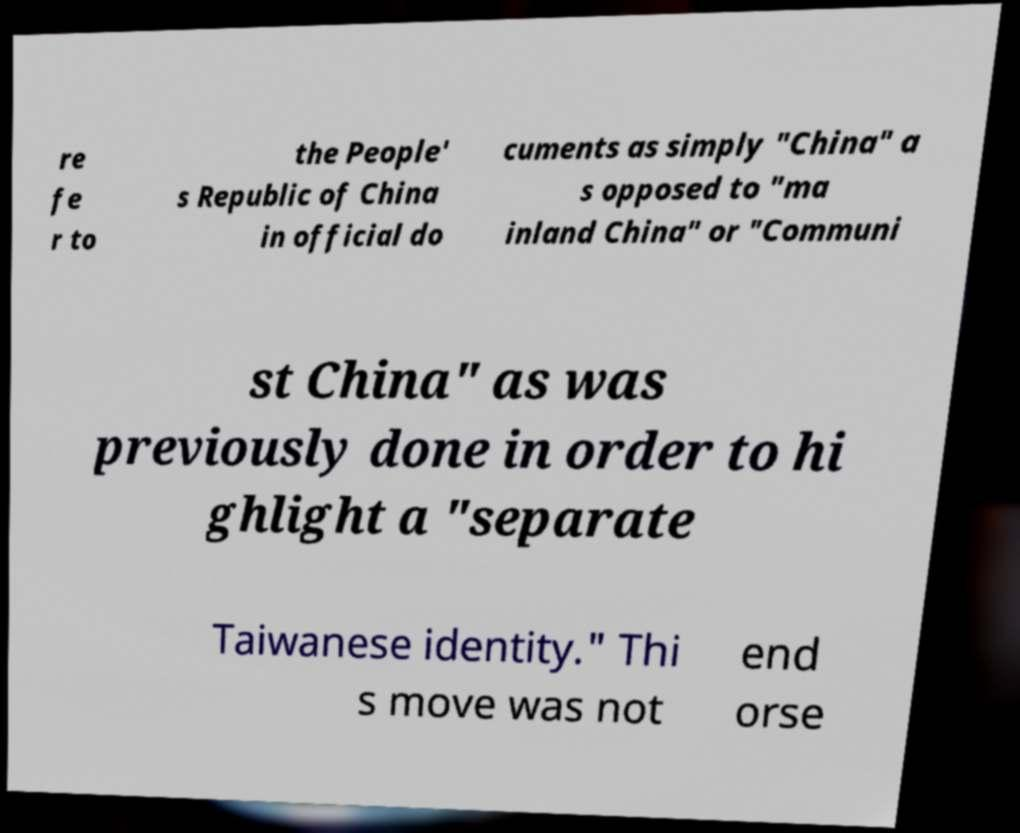What messages or text are displayed in this image? I need them in a readable, typed format. re fe r to the People' s Republic of China in official do cuments as simply "China" a s opposed to "ma inland China" or "Communi st China" as was previously done in order to hi ghlight a "separate Taiwanese identity." Thi s move was not end orse 